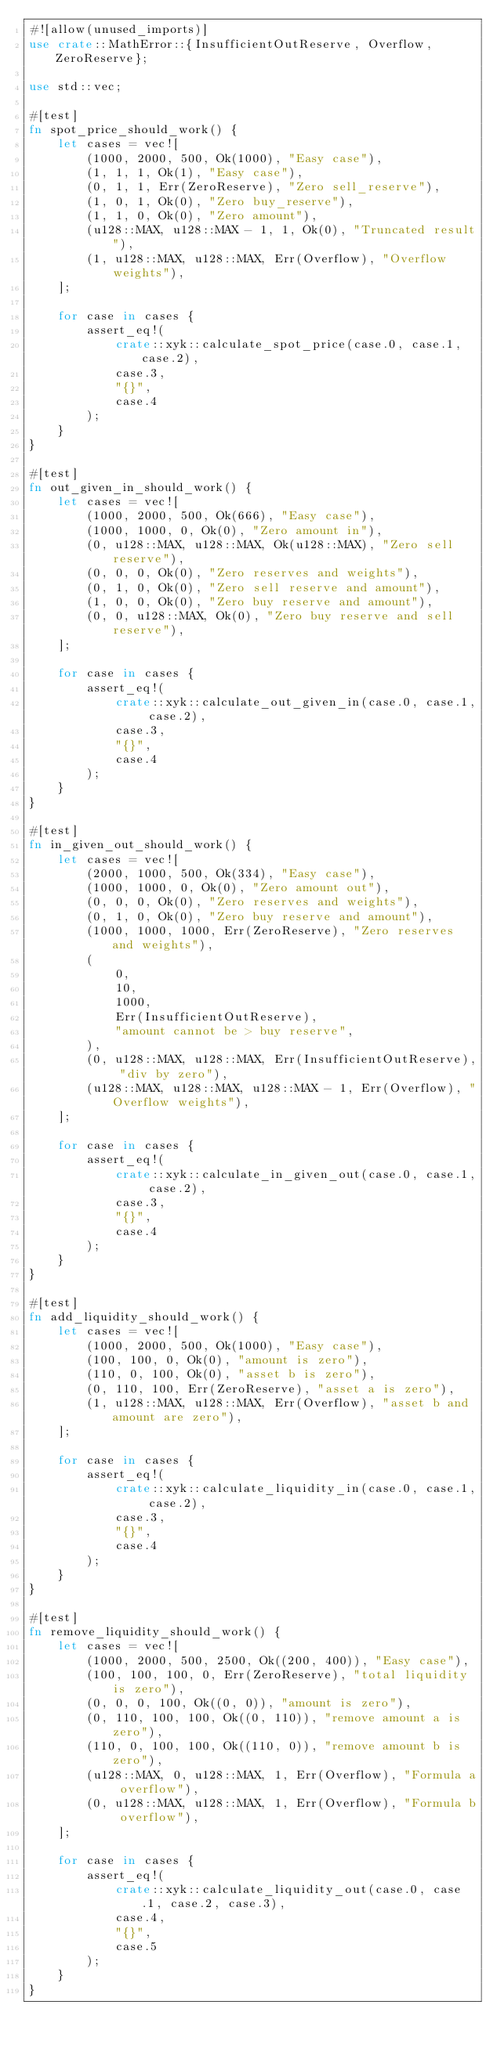<code> <loc_0><loc_0><loc_500><loc_500><_Rust_>#![allow(unused_imports)]
use crate::MathError::{InsufficientOutReserve, Overflow, ZeroReserve};

use std::vec;

#[test]
fn spot_price_should_work() {
    let cases = vec![
        (1000, 2000, 500, Ok(1000), "Easy case"),
        (1, 1, 1, Ok(1), "Easy case"),
        (0, 1, 1, Err(ZeroReserve), "Zero sell_reserve"),
        (1, 0, 1, Ok(0), "Zero buy_reserve"),
        (1, 1, 0, Ok(0), "Zero amount"),
        (u128::MAX, u128::MAX - 1, 1, Ok(0), "Truncated result"),
        (1, u128::MAX, u128::MAX, Err(Overflow), "Overflow weights"),
    ];

    for case in cases {
        assert_eq!(
            crate::xyk::calculate_spot_price(case.0, case.1, case.2),
            case.3,
            "{}",
            case.4
        );
    }
}

#[test]
fn out_given_in_should_work() {
    let cases = vec![
        (1000, 2000, 500, Ok(666), "Easy case"),
        (1000, 1000, 0, Ok(0), "Zero amount in"),
        (0, u128::MAX, u128::MAX, Ok(u128::MAX), "Zero sell reserve"),
        (0, 0, 0, Ok(0), "Zero reserves and weights"),
        (0, 1, 0, Ok(0), "Zero sell reserve and amount"),
        (1, 0, 0, Ok(0), "Zero buy reserve and amount"),
        (0, 0, u128::MAX, Ok(0), "Zero buy reserve and sell reserve"),
    ];

    for case in cases {
        assert_eq!(
            crate::xyk::calculate_out_given_in(case.0, case.1, case.2),
            case.3,
            "{}",
            case.4
        );
    }
}

#[test]
fn in_given_out_should_work() {
    let cases = vec![
        (2000, 1000, 500, Ok(334), "Easy case"),
        (1000, 1000, 0, Ok(0), "Zero amount out"),
        (0, 0, 0, Ok(0), "Zero reserves and weights"),
        (0, 1, 0, Ok(0), "Zero buy reserve and amount"),
        (1000, 1000, 1000, Err(ZeroReserve), "Zero reserves and weights"),
        (
            0,
            10,
            1000,
            Err(InsufficientOutReserve),
            "amount cannot be > buy reserve",
        ),
        (0, u128::MAX, u128::MAX, Err(InsufficientOutReserve), "div by zero"),
        (u128::MAX, u128::MAX, u128::MAX - 1, Err(Overflow), "Overflow weights"),
    ];

    for case in cases {
        assert_eq!(
            crate::xyk::calculate_in_given_out(case.0, case.1, case.2),
            case.3,
            "{}",
            case.4
        );
    }
}

#[test]
fn add_liquidity_should_work() {
    let cases = vec![
        (1000, 2000, 500, Ok(1000), "Easy case"),
        (100, 100, 0, Ok(0), "amount is zero"),
        (110, 0, 100, Ok(0), "asset b is zero"),
        (0, 110, 100, Err(ZeroReserve), "asset a is zero"),
        (1, u128::MAX, u128::MAX, Err(Overflow), "asset b and amount are zero"),
    ];

    for case in cases {
        assert_eq!(
            crate::xyk::calculate_liquidity_in(case.0, case.1, case.2),
            case.3,
            "{}",
            case.4
        );
    }
}

#[test]
fn remove_liquidity_should_work() {
    let cases = vec![
        (1000, 2000, 500, 2500, Ok((200, 400)), "Easy case"),
        (100, 100, 100, 0, Err(ZeroReserve), "total liquidity is zero"),
        (0, 0, 0, 100, Ok((0, 0)), "amount is zero"),
        (0, 110, 100, 100, Ok((0, 110)), "remove amount a is zero"),
        (110, 0, 100, 100, Ok((110, 0)), "remove amount b is zero"),
        (u128::MAX, 0, u128::MAX, 1, Err(Overflow), "Formula a overflow"),
        (0, u128::MAX, u128::MAX, 1, Err(Overflow), "Formula b overflow"),
    ];

    for case in cases {
        assert_eq!(
            crate::xyk::calculate_liquidity_out(case.0, case.1, case.2, case.3),
            case.4,
            "{}",
            case.5
        );
    }
}
</code> 